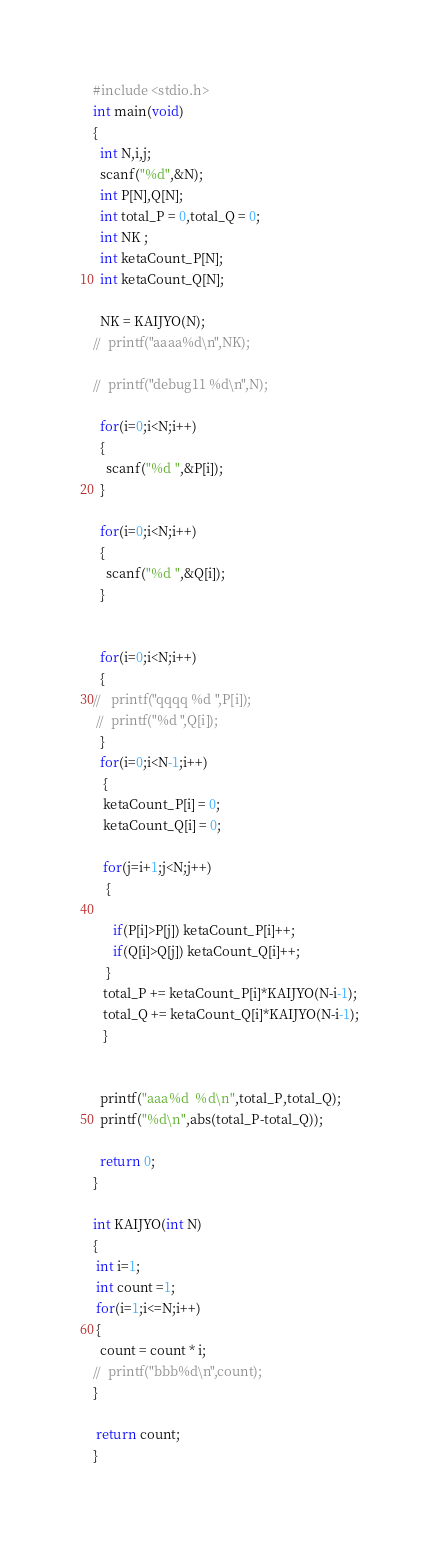Convert code to text. <code><loc_0><loc_0><loc_500><loc_500><_C_>#include <stdio.h>
int main(void)
{
  int N,i,j;
  scanf("%d",&N);
  int P[N],Q[N];
  int total_P = 0,total_Q = 0;
  int NK ;
  int ketaCount_P[N]; 
  int ketaCount_Q[N]; 

  NK = KAIJYO(N);
//  printf("aaaa%d\n",NK);

//  printf("debug11 %d\n",N);

  for(i=0;i<N;i++)
  {
    scanf("%d ",&P[i]);
  }

  for(i=0;i<N;i++)
  {
    scanf("%d ",&Q[i]);
  }


  for(i=0;i<N;i++)
  {
//   printf("qqqq %d ",P[i]);
 //  printf("%d ",Q[i]);
  }
  for(i=0;i<N-1;i++) 
   {
   ketaCount_P[i] = 0;
   ketaCount_Q[i] = 0;

   for(j=i+1;j<N;j++)
    {

      if(P[i]>P[j]) ketaCount_P[i]++;
      if(Q[i]>Q[j]) ketaCount_Q[i]++;
    }
   total_P += ketaCount_P[i]*KAIJYO(N-i-1);
   total_Q += ketaCount_Q[i]*KAIJYO(N-i-1);
   }


  printf("aaa%d  %d\n",total_P,total_Q);
  printf("%d\n",abs(total_P-total_Q));

  return 0;
}

int KAIJYO(int N)
{
 int i=1;
 int count =1;
 for(i=1;i<=N;i++)
 {
  count = count * i;
//  printf("bbb%d\n",count);
}

 return count; 
}
</code> 